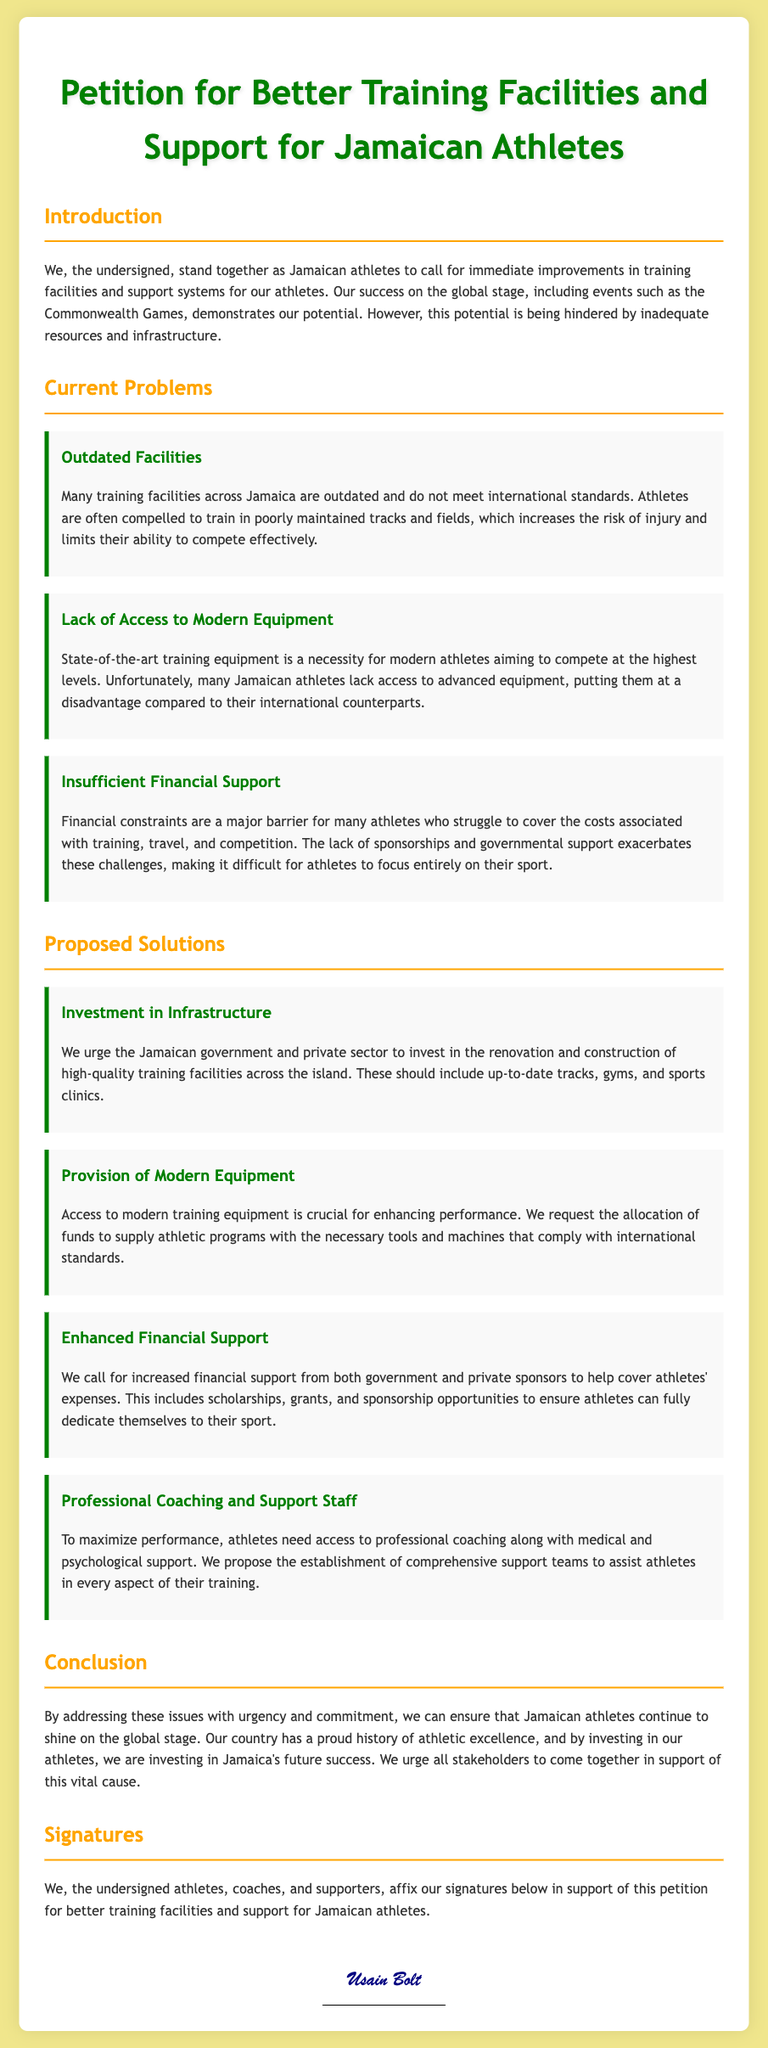What is the title of the petition? The title of the petition is presented as a heading at the top of the document.
Answer: Petition for Better Training Facilities and Support for Jamaican Athletes What are the current problems highlighted in the petition? The document lists several issues under the "Current Problems" section.
Answer: Outdated Facilities, Lack of Access to Modern Equipment, Insufficient Financial Support How many proposed solutions are outlined in the petition? The document mentions specific solutions in the "Proposed Solutions" section that follows the problems.
Answer: Four What is the first proposed solution mentioned? The first solution is detailed in the "Proposed Solutions" section of the document.
Answer: Investment in Infrastructure Who is one of the signatories of the petition? The document lists a signature under the "Signatures" section as an example of support.
Answer: Usain Bolt What is the background color of the document? The document's background color is specified in the style settings.
Answer: Light yellow (f0e68c) What is the suggested funding purpose mentioned in the petition? The text suggests a specific use for increased financial support in the "Enhanced Financial Support" section.
Answer: Cover athletes' expenses What is one of the reasons for the lack of modern training? The reasons for inadequate training facilities are detailed in the "Current Problems" section.
Answer: Financial constraints What is the conclusion’s main call to action? The conclusion summarizes the petition’s overall appeal and necessity for support.
Answer: Urgent improvements for athletes 